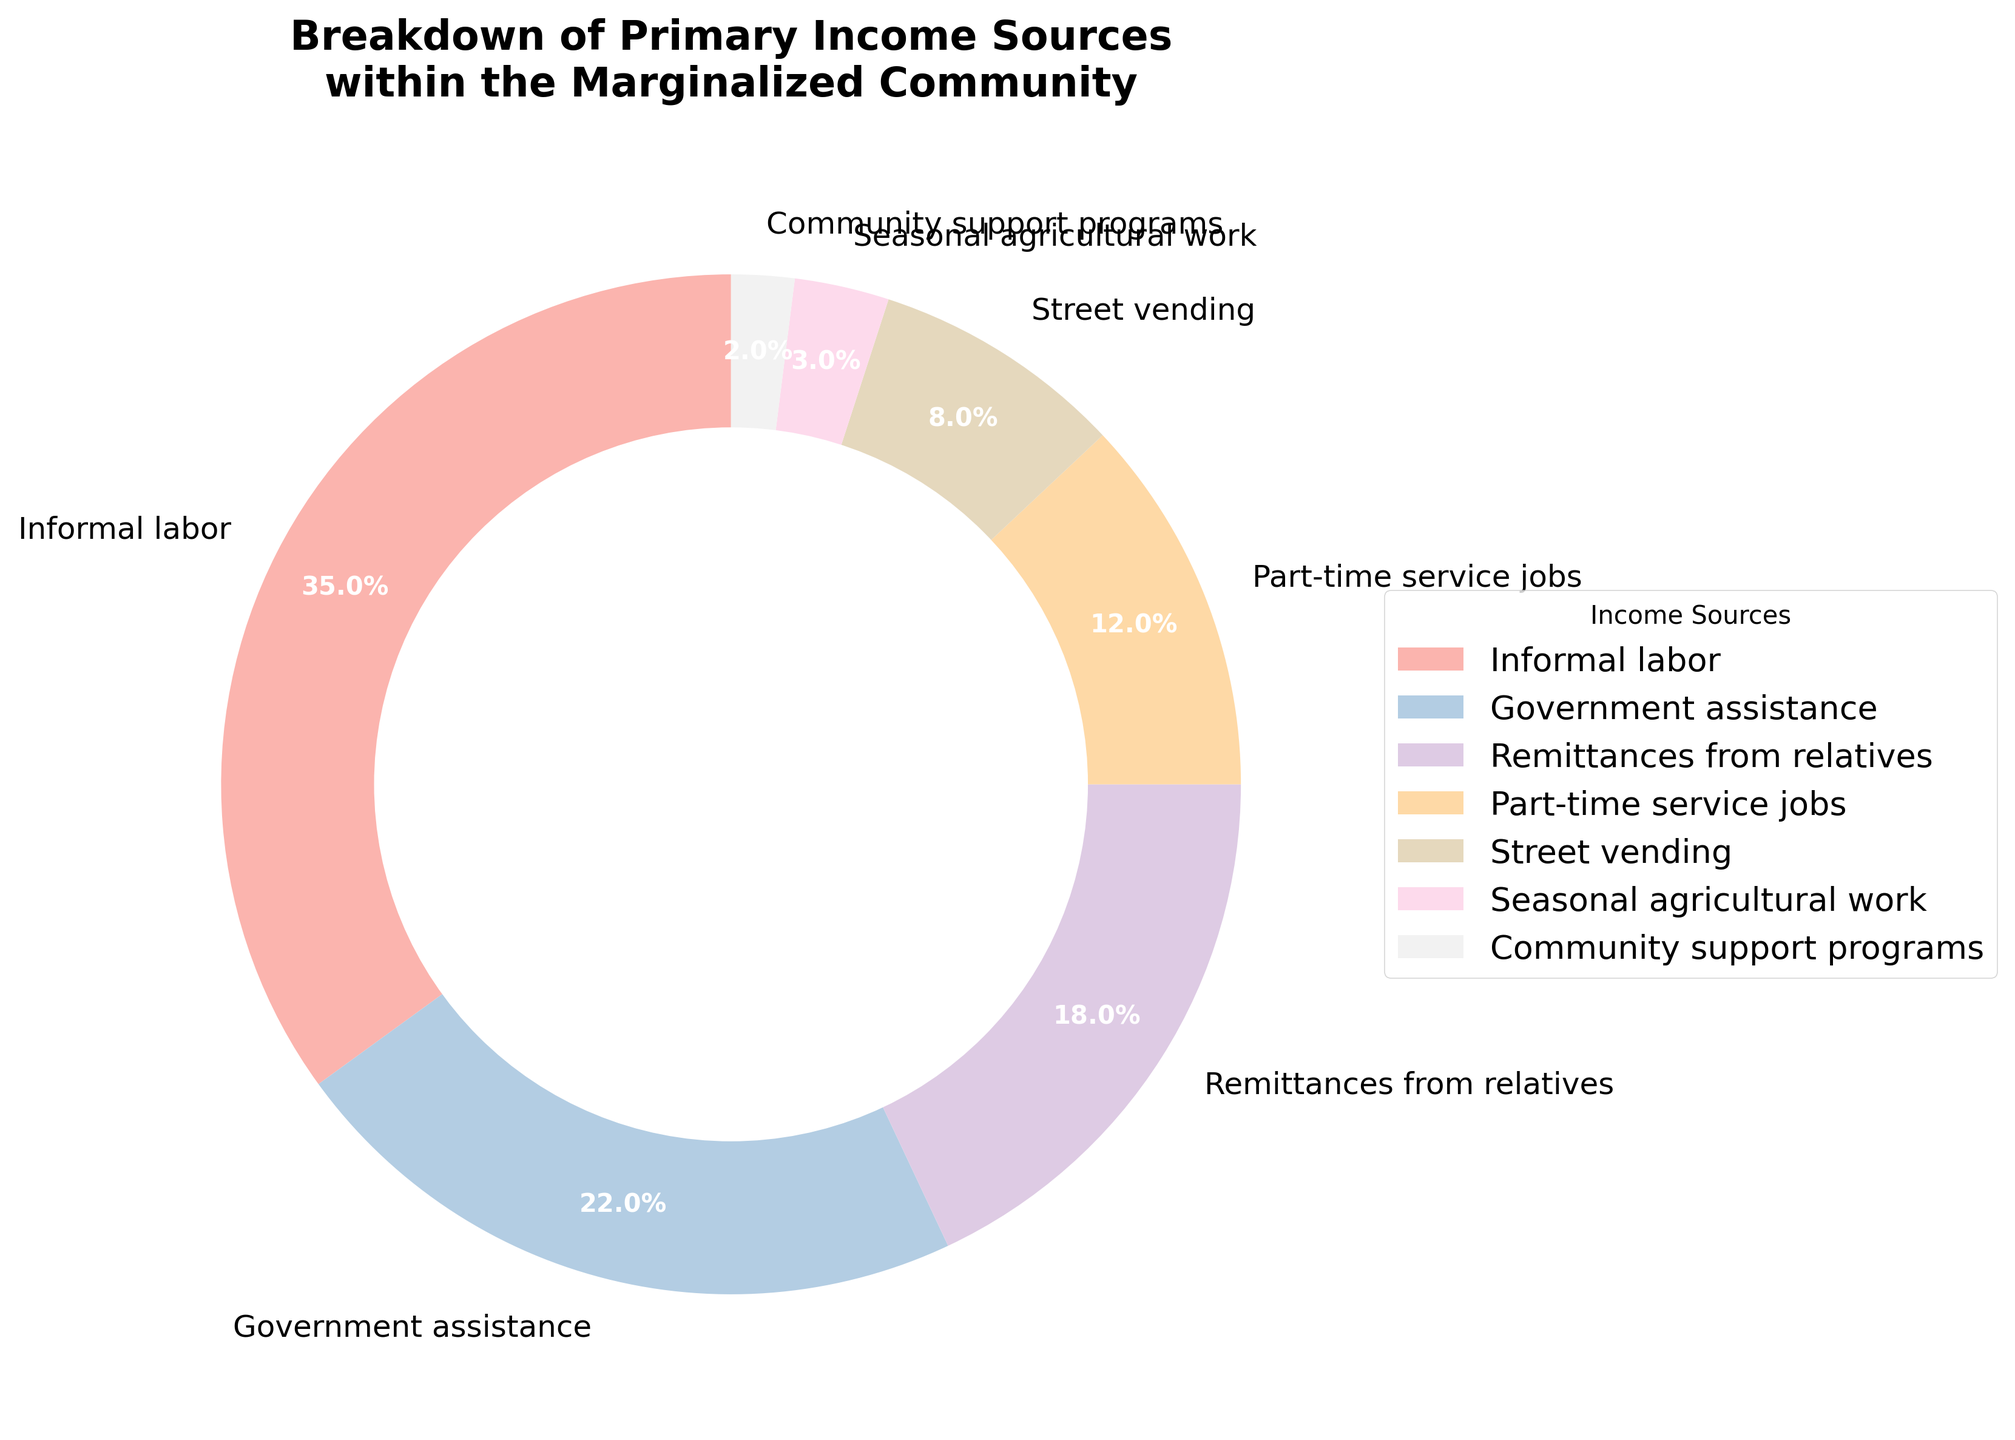what is the combined percentage of government assistance and community support programs? To find the combined percentage, sum the percentages of government assistance and community support programs: 22% (government assistance) + 2% (community support programs) = 24%
Answer: 24% which income source has the largest percentage? The largest segment of the pie chart is represented by informal labor, which has a 35% share.
Answer: Informal labor how much larger is the share of informal labor compared to part-time service jobs? To find the difference, subtract the percentage of part-time service jobs from the percentage of informal labor: 35% (informal labor) - 12% (part-time service jobs) = 23%
Answer: 23% what is the average percentage of street vending and seasonal agricultural work? Sum the percentages of street vending and seasonal agricultural work and then divide by 2: (8% + 3%) / 2 = 5.5%
Answer: 5.5% which income sources contribute the smallest percentage? The smallest segments of the pie chart are Community support programs (2%) and Seasonal agricultural work (3%).
Answer: Community support programs and Seasonal agricultural work what is the percentage difference between remittances from relatives and informal labor? Subtract the percentage of remittances from relatives from the percentage of informal labor: 35% (informal labor) - 18% (remittances from relatives) = 17%
Answer: 17% what percentage of income comes from sources contributing less than 10% each? Sum the percentages of sources contributing less than 10%: 8% (street vending) + 3% (seasonal agricultural work) + 2% (community support programs) = 13%
Answer: 13% which income source is represented by the lightest color in the pie chart? Considering that the colors follow the 'Pastel1' colormap and generally range from lighter to darker shades, the lightest segment is likely to be Community support programs (2%).
Answer: Community support programs how many income sources have a larger share than remittances from relatives? Remittances from relatives is at 18%. The income sources with a larger share are Informal labor (35%) and Government assistance (22%), making it two income sources.
Answer: two 